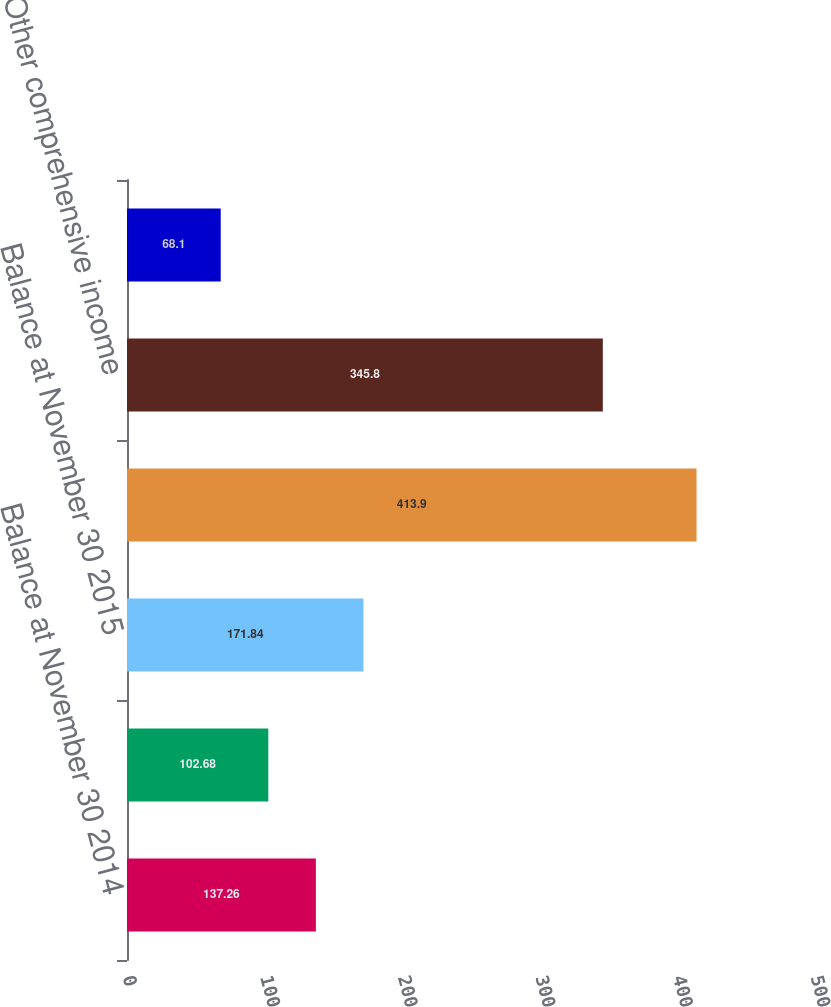Convert chart. <chart><loc_0><loc_0><loc_500><loc_500><bar_chart><fcel>Balance at November 30 2014<fcel>Other comprehensive loss<fcel>Balance at November 30 2015<fcel>Balance at November 30 2016<fcel>Other comprehensive income<fcel>Balance at November 30 2017<nl><fcel>137.26<fcel>102.68<fcel>171.84<fcel>413.9<fcel>345.8<fcel>68.1<nl></chart> 